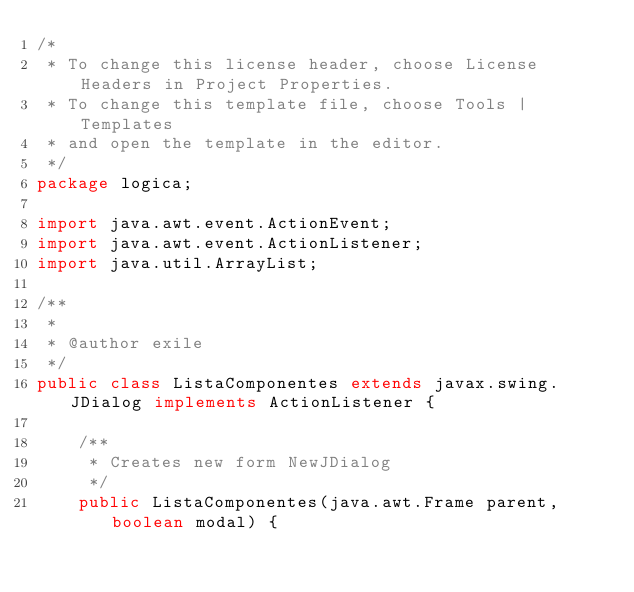Convert code to text. <code><loc_0><loc_0><loc_500><loc_500><_Java_>/*
 * To change this license header, choose License Headers in Project Properties.
 * To change this template file, choose Tools | Templates
 * and open the template in the editor.
 */
package logica;

import java.awt.event.ActionEvent;
import java.awt.event.ActionListener;
import java.util.ArrayList;

/**
 *
 * @author exile
 */
public class ListaComponentes extends javax.swing.JDialog implements ActionListener {

    /**
     * Creates new form NewJDialog
     */
    public ListaComponentes(java.awt.Frame parent, boolean modal) {</code> 